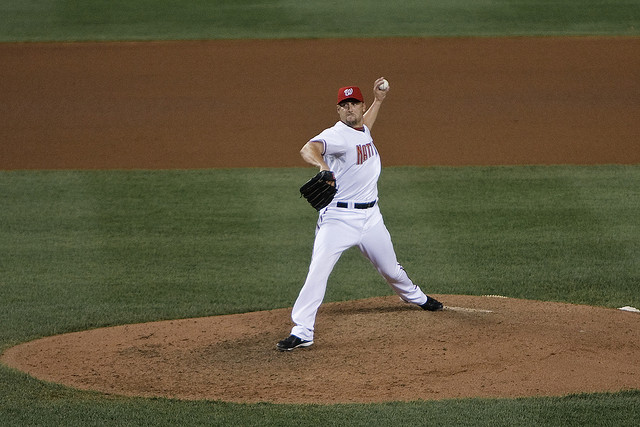<image>What team just scored a run? I don't know what team just scored a run. It can be Indians, Nationals, Braves, Mets, Dodgers or the opposite team. What team just scored a run? It is unknown what team just scored a run. 